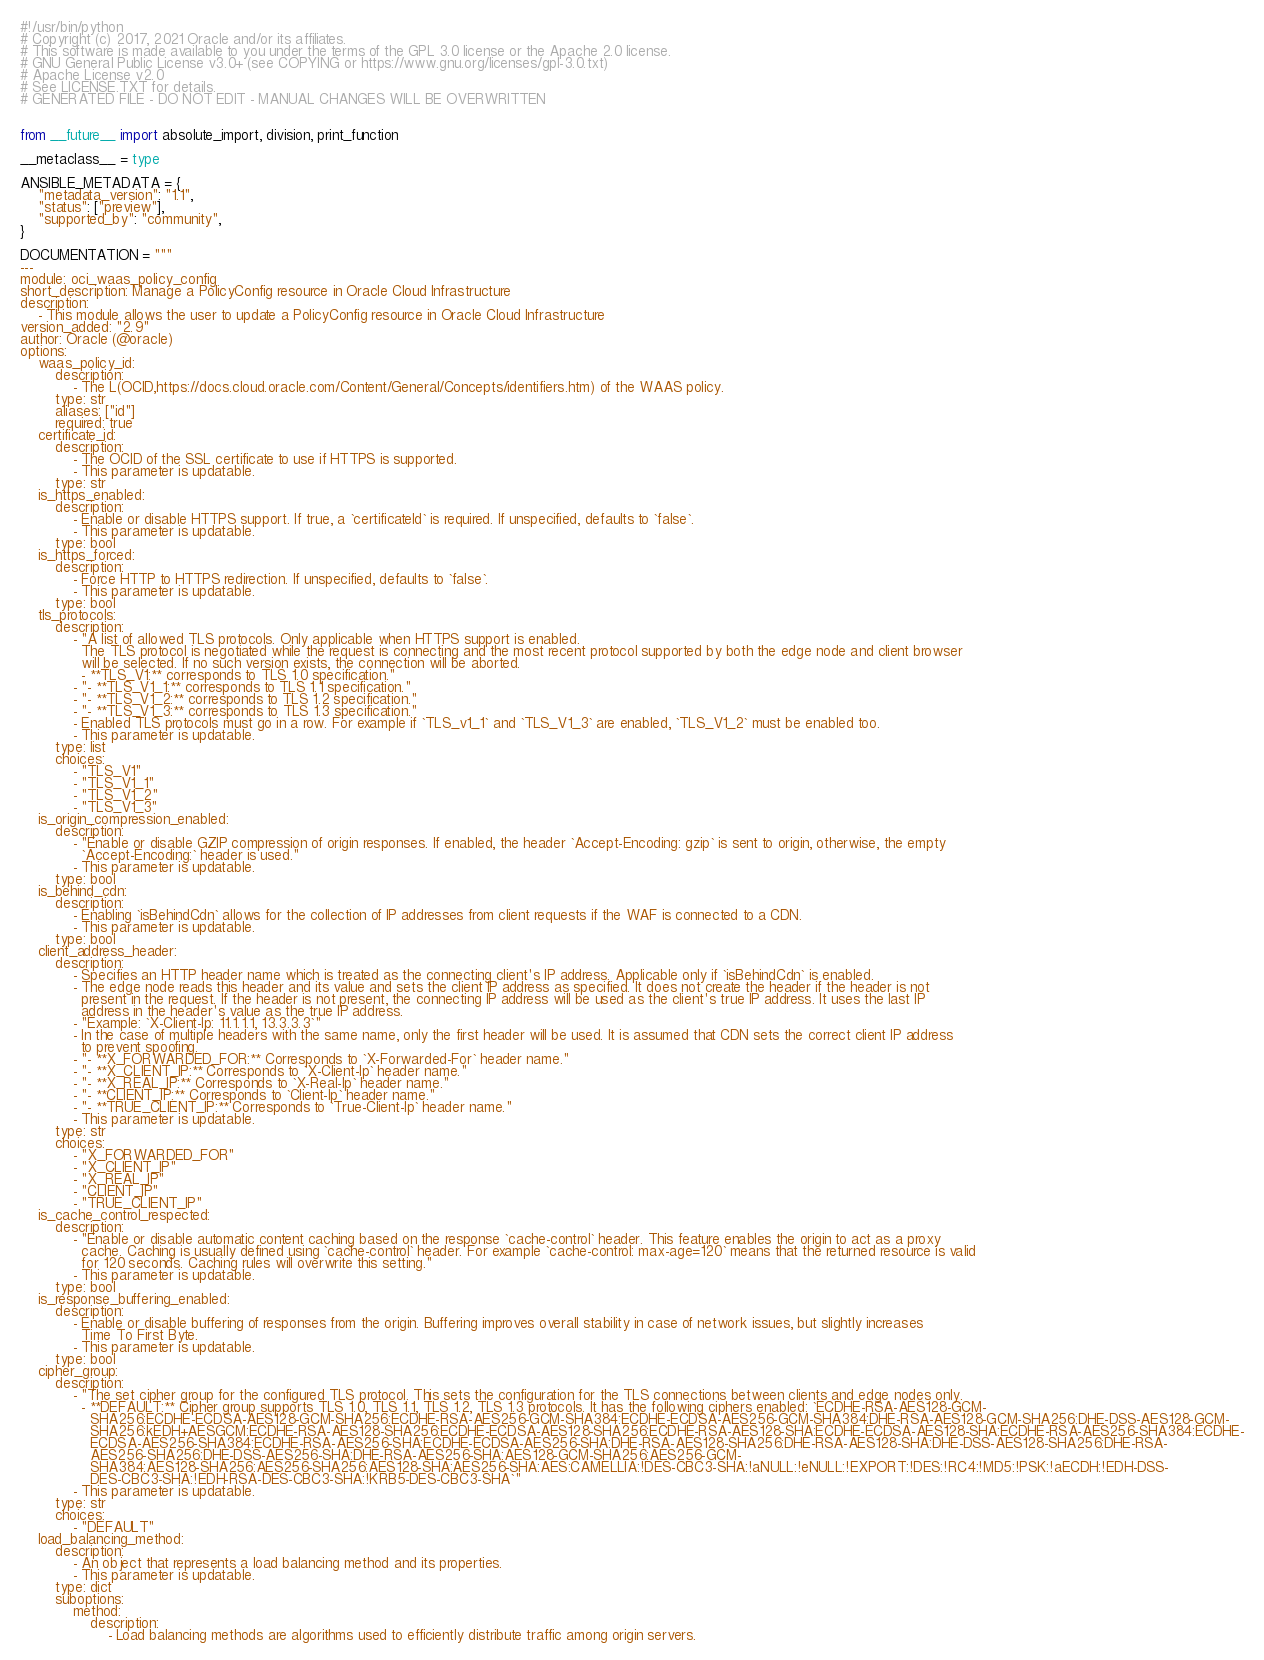<code> <loc_0><loc_0><loc_500><loc_500><_Python_>#!/usr/bin/python
# Copyright (c) 2017, 2021 Oracle and/or its affiliates.
# This software is made available to you under the terms of the GPL 3.0 license or the Apache 2.0 license.
# GNU General Public License v3.0+ (see COPYING or https://www.gnu.org/licenses/gpl-3.0.txt)
# Apache License v2.0
# See LICENSE.TXT for details.
# GENERATED FILE - DO NOT EDIT - MANUAL CHANGES WILL BE OVERWRITTEN


from __future__ import absolute_import, division, print_function

__metaclass__ = type

ANSIBLE_METADATA = {
    "metadata_version": "1.1",
    "status": ["preview"],
    "supported_by": "community",
}

DOCUMENTATION = """
---
module: oci_waas_policy_config
short_description: Manage a PolicyConfig resource in Oracle Cloud Infrastructure
description:
    - This module allows the user to update a PolicyConfig resource in Oracle Cloud Infrastructure
version_added: "2.9"
author: Oracle (@oracle)
options:
    waas_policy_id:
        description:
            - The L(OCID,https://docs.cloud.oracle.com/Content/General/Concepts/identifiers.htm) of the WAAS policy.
        type: str
        aliases: ["id"]
        required: true
    certificate_id:
        description:
            - The OCID of the SSL certificate to use if HTTPS is supported.
            - This parameter is updatable.
        type: str
    is_https_enabled:
        description:
            - Enable or disable HTTPS support. If true, a `certificateId` is required. If unspecified, defaults to `false`.
            - This parameter is updatable.
        type: bool
    is_https_forced:
        description:
            - Force HTTP to HTTPS redirection. If unspecified, defaults to `false`.
            - This parameter is updatable.
        type: bool
    tls_protocols:
        description:
            - "A list of allowed TLS protocols. Only applicable when HTTPS support is enabled.
              The TLS protocol is negotiated while the request is connecting and the most recent protocol supported by both the edge node and client browser
              will be selected. If no such version exists, the connection will be aborted.
              - **TLS_V1:** corresponds to TLS 1.0 specification."
            - "- **TLS_V1_1:** corresponds to TLS 1.1 specification."
            - "- **TLS_V1_2:** corresponds to TLS 1.2 specification."
            - "- **TLS_V1_3:** corresponds to TLS 1.3 specification."
            - Enabled TLS protocols must go in a row. For example if `TLS_v1_1` and `TLS_V1_3` are enabled, `TLS_V1_2` must be enabled too.
            - This parameter is updatable.
        type: list
        choices:
            - "TLS_V1"
            - "TLS_V1_1"
            - "TLS_V1_2"
            - "TLS_V1_3"
    is_origin_compression_enabled:
        description:
            - "Enable or disable GZIP compression of origin responses. If enabled, the header `Accept-Encoding: gzip` is sent to origin, otherwise, the empty
              `Accept-Encoding:` header is used."
            - This parameter is updatable.
        type: bool
    is_behind_cdn:
        description:
            - Enabling `isBehindCdn` allows for the collection of IP addresses from client requests if the WAF is connected to a CDN.
            - This parameter is updatable.
        type: bool
    client_address_header:
        description:
            - Specifies an HTTP header name which is treated as the connecting client's IP address. Applicable only if `isBehindCdn` is enabled.
            - The edge node reads this header and its value and sets the client IP address as specified. It does not create the header if the header is not
              present in the request. If the header is not present, the connecting IP address will be used as the client's true IP address. It uses the last IP
              address in the header's value as the true IP address.
            - "Example: `X-Client-Ip: 11.1.1.1, 13.3.3.3`"
            - In the case of multiple headers with the same name, only the first header will be used. It is assumed that CDN sets the correct client IP address
              to prevent spoofing.
            - "- **X_FORWARDED_FOR:** Corresponds to `X-Forwarded-For` header name."
            - "- **X_CLIENT_IP:** Corresponds to `X-Client-Ip` header name."
            - "- **X_REAL_IP:** Corresponds to `X-Real-Ip` header name."
            - "- **CLIENT_IP:** Corresponds to `Client-Ip` header name."
            - "- **TRUE_CLIENT_IP:** Corresponds to `True-Client-Ip` header name."
            - This parameter is updatable.
        type: str
        choices:
            - "X_FORWARDED_FOR"
            - "X_CLIENT_IP"
            - "X_REAL_IP"
            - "CLIENT_IP"
            - "TRUE_CLIENT_IP"
    is_cache_control_respected:
        description:
            - "Enable or disable automatic content caching based on the response `cache-control` header. This feature enables the origin to act as a proxy
              cache. Caching is usually defined using `cache-control` header. For example `cache-control: max-age=120` means that the returned resource is valid
              for 120 seconds. Caching rules will overwrite this setting."
            - This parameter is updatable.
        type: bool
    is_response_buffering_enabled:
        description:
            - Enable or disable buffering of responses from the origin. Buffering improves overall stability in case of network issues, but slightly increases
              Time To First Byte.
            - This parameter is updatable.
        type: bool
    cipher_group:
        description:
            - "The set cipher group for the configured TLS protocol. This sets the configuration for the TLS connections between clients and edge nodes only.
              - **DEFAULT:** Cipher group supports TLS 1.0, TLS 1.1, TLS 1.2, TLS 1.3 protocols. It has the following ciphers enabled: `ECDHE-RSA-AES128-GCM-
                SHA256:ECDHE-ECDSA-AES128-GCM-SHA256:ECDHE-RSA-AES256-GCM-SHA384:ECDHE-ECDSA-AES256-GCM-SHA384:DHE-RSA-AES128-GCM-SHA256:DHE-DSS-AES128-GCM-
                SHA256:kEDH+AESGCM:ECDHE-RSA-AES128-SHA256:ECDHE-ECDSA-AES128-SHA256:ECDHE-RSA-AES128-SHA:ECDHE-ECDSA-AES128-SHA:ECDHE-RSA-AES256-SHA384:ECDHE-
                ECDSA-AES256-SHA384:ECDHE-RSA-AES256-SHA:ECDHE-ECDSA-AES256-SHA:DHE-RSA-AES128-SHA256:DHE-RSA-AES128-SHA:DHE-DSS-AES128-SHA256:DHE-RSA-
                AES256-SHA256:DHE-DSS-AES256-SHA:DHE-RSA-AES256-SHA:AES128-GCM-SHA256:AES256-GCM-
                SHA384:AES128-SHA256:AES256-SHA256:AES128-SHA:AES256-SHA:AES:CAMELLIA:!DES-CBC3-SHA:!aNULL:!eNULL:!EXPORT:!DES:!RC4:!MD5:!PSK:!aECDH:!EDH-DSS-
                DES-CBC3-SHA:!EDH-RSA-DES-CBC3-SHA:!KRB5-DES-CBC3-SHA`"
            - This parameter is updatable.
        type: str
        choices:
            - "DEFAULT"
    load_balancing_method:
        description:
            - An object that represents a load balancing method and its properties.
            - This parameter is updatable.
        type: dict
        suboptions:
            method:
                description:
                    - Load balancing methods are algorithms used to efficiently distribute traffic among origin servers.</code> 